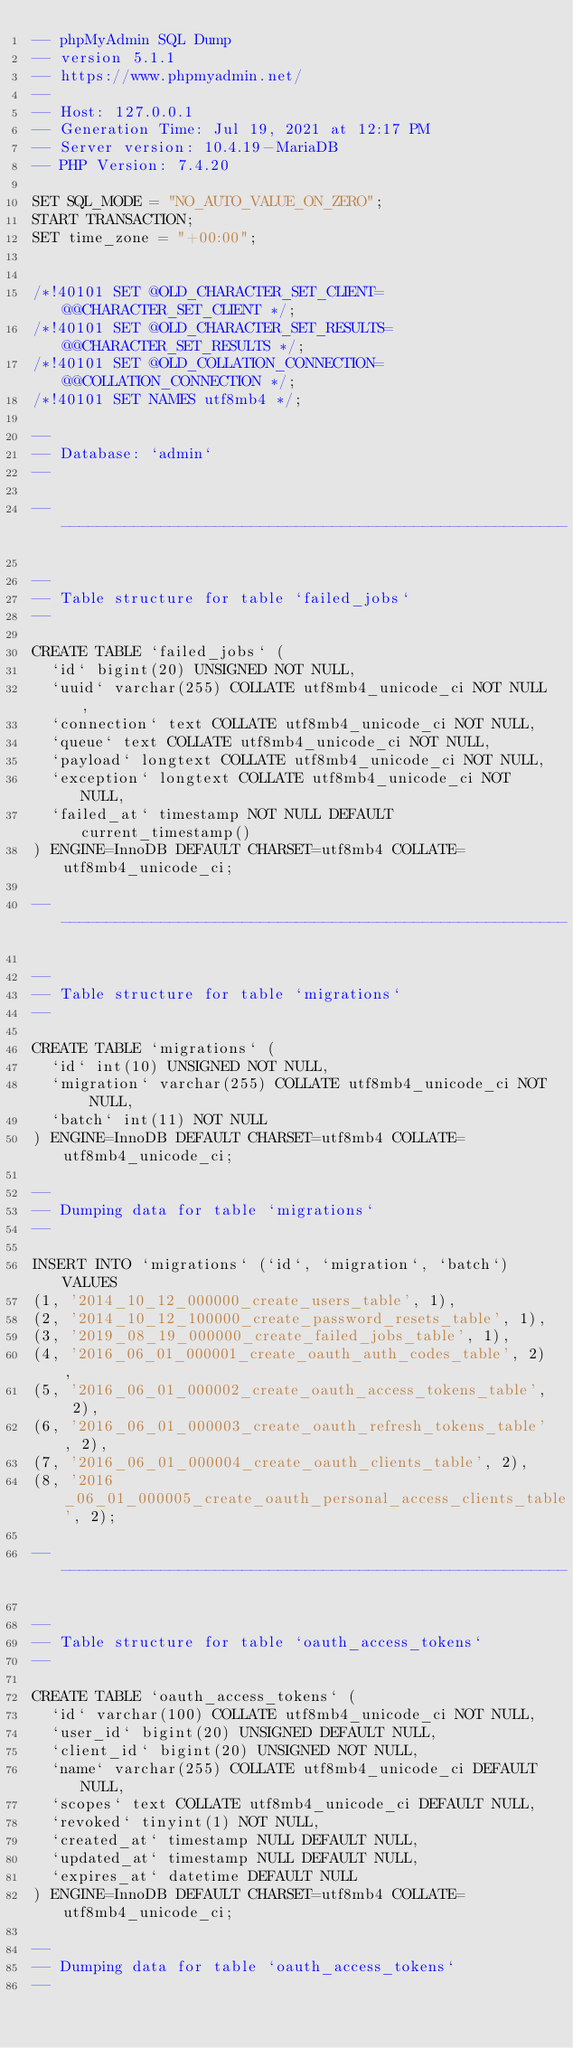Convert code to text. <code><loc_0><loc_0><loc_500><loc_500><_SQL_>-- phpMyAdmin SQL Dump
-- version 5.1.1
-- https://www.phpmyadmin.net/
--
-- Host: 127.0.0.1
-- Generation Time: Jul 19, 2021 at 12:17 PM
-- Server version: 10.4.19-MariaDB
-- PHP Version: 7.4.20

SET SQL_MODE = "NO_AUTO_VALUE_ON_ZERO";
START TRANSACTION;
SET time_zone = "+00:00";


/*!40101 SET @OLD_CHARACTER_SET_CLIENT=@@CHARACTER_SET_CLIENT */;
/*!40101 SET @OLD_CHARACTER_SET_RESULTS=@@CHARACTER_SET_RESULTS */;
/*!40101 SET @OLD_COLLATION_CONNECTION=@@COLLATION_CONNECTION */;
/*!40101 SET NAMES utf8mb4 */;

--
-- Database: `admin`
--

-- --------------------------------------------------------

--
-- Table structure for table `failed_jobs`
--

CREATE TABLE `failed_jobs` (
  `id` bigint(20) UNSIGNED NOT NULL,
  `uuid` varchar(255) COLLATE utf8mb4_unicode_ci NOT NULL,
  `connection` text COLLATE utf8mb4_unicode_ci NOT NULL,
  `queue` text COLLATE utf8mb4_unicode_ci NOT NULL,
  `payload` longtext COLLATE utf8mb4_unicode_ci NOT NULL,
  `exception` longtext COLLATE utf8mb4_unicode_ci NOT NULL,
  `failed_at` timestamp NOT NULL DEFAULT current_timestamp()
) ENGINE=InnoDB DEFAULT CHARSET=utf8mb4 COLLATE=utf8mb4_unicode_ci;

-- --------------------------------------------------------

--
-- Table structure for table `migrations`
--

CREATE TABLE `migrations` (
  `id` int(10) UNSIGNED NOT NULL,
  `migration` varchar(255) COLLATE utf8mb4_unicode_ci NOT NULL,
  `batch` int(11) NOT NULL
) ENGINE=InnoDB DEFAULT CHARSET=utf8mb4 COLLATE=utf8mb4_unicode_ci;

--
-- Dumping data for table `migrations`
--

INSERT INTO `migrations` (`id`, `migration`, `batch`) VALUES
(1, '2014_10_12_000000_create_users_table', 1),
(2, '2014_10_12_100000_create_password_resets_table', 1),
(3, '2019_08_19_000000_create_failed_jobs_table', 1),
(4, '2016_06_01_000001_create_oauth_auth_codes_table', 2),
(5, '2016_06_01_000002_create_oauth_access_tokens_table', 2),
(6, '2016_06_01_000003_create_oauth_refresh_tokens_table', 2),
(7, '2016_06_01_000004_create_oauth_clients_table', 2),
(8, '2016_06_01_000005_create_oauth_personal_access_clients_table', 2);

-- --------------------------------------------------------

--
-- Table structure for table `oauth_access_tokens`
--

CREATE TABLE `oauth_access_tokens` (
  `id` varchar(100) COLLATE utf8mb4_unicode_ci NOT NULL,
  `user_id` bigint(20) UNSIGNED DEFAULT NULL,
  `client_id` bigint(20) UNSIGNED NOT NULL,
  `name` varchar(255) COLLATE utf8mb4_unicode_ci DEFAULT NULL,
  `scopes` text COLLATE utf8mb4_unicode_ci DEFAULT NULL,
  `revoked` tinyint(1) NOT NULL,
  `created_at` timestamp NULL DEFAULT NULL,
  `updated_at` timestamp NULL DEFAULT NULL,
  `expires_at` datetime DEFAULT NULL
) ENGINE=InnoDB DEFAULT CHARSET=utf8mb4 COLLATE=utf8mb4_unicode_ci;

--
-- Dumping data for table `oauth_access_tokens`
--
</code> 